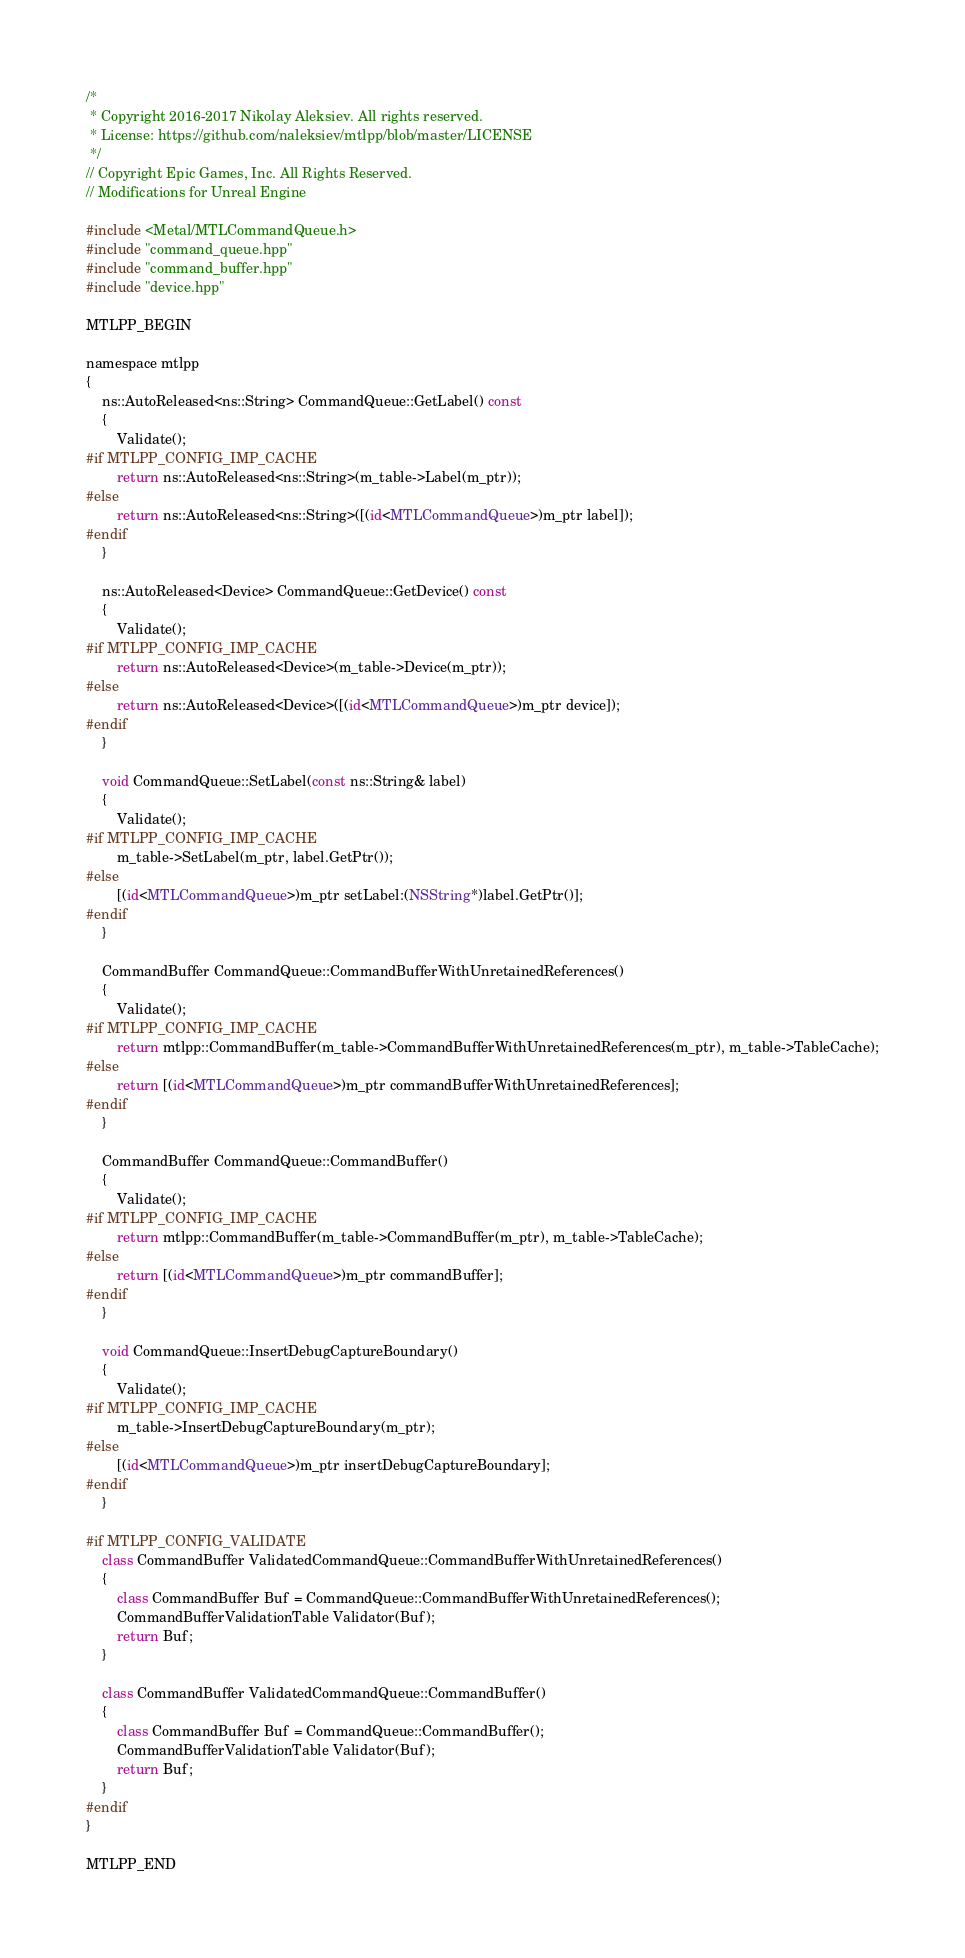Convert code to text. <code><loc_0><loc_0><loc_500><loc_500><_ObjectiveC_>/*
 * Copyright 2016-2017 Nikolay Aleksiev. All rights reserved.
 * License: https://github.com/naleksiev/mtlpp/blob/master/LICENSE
 */
// Copyright Epic Games, Inc. All Rights Reserved.
// Modifications for Unreal Engine

#include <Metal/MTLCommandQueue.h>
#include "command_queue.hpp"
#include "command_buffer.hpp"
#include "device.hpp"

MTLPP_BEGIN

namespace mtlpp
{
    ns::AutoReleased<ns::String> CommandQueue::GetLabel() const
    {
        Validate();
#if MTLPP_CONFIG_IMP_CACHE
		return ns::AutoReleased<ns::String>(m_table->Label(m_ptr));
#else
        return ns::AutoReleased<ns::String>([(id<MTLCommandQueue>)m_ptr label]);
#endif
    }

    ns::AutoReleased<Device> CommandQueue::GetDevice() const
    {
        Validate();
#if MTLPP_CONFIG_IMP_CACHE
		return ns::AutoReleased<Device>(m_table->Device(m_ptr));
#else
        return ns::AutoReleased<Device>([(id<MTLCommandQueue>)m_ptr device]);
#endif
    }

    void CommandQueue::SetLabel(const ns::String& label)
    {
        Validate();
#if MTLPP_CONFIG_IMP_CACHE
		m_table->SetLabel(m_ptr, label.GetPtr());
#else
        [(id<MTLCommandQueue>)m_ptr setLabel:(NSString*)label.GetPtr()];
#endif
    }

    CommandBuffer CommandQueue::CommandBufferWithUnretainedReferences()
    {
        Validate();
#if MTLPP_CONFIG_IMP_CACHE
		return mtlpp::CommandBuffer(m_table->CommandBufferWithUnretainedReferences(m_ptr), m_table->TableCache);
#else
        return [(id<MTLCommandQueue>)m_ptr commandBufferWithUnretainedReferences];
#endif
    }

    CommandBuffer CommandQueue::CommandBuffer()
    {
        Validate();
#if MTLPP_CONFIG_IMP_CACHE
		return mtlpp::CommandBuffer(m_table->CommandBuffer(m_ptr), m_table->TableCache);
#else
        return [(id<MTLCommandQueue>)m_ptr commandBuffer];
#endif
    }

    void CommandQueue::InsertDebugCaptureBoundary()
    {
        Validate();
#if MTLPP_CONFIG_IMP_CACHE
		m_table->InsertDebugCaptureBoundary(m_ptr);
#else
        [(id<MTLCommandQueue>)m_ptr insertDebugCaptureBoundary];
#endif
    }
	
#if MTLPP_CONFIG_VALIDATE
	class CommandBuffer ValidatedCommandQueue::CommandBufferWithUnretainedReferences()
	{
		class CommandBuffer Buf = CommandQueue::CommandBufferWithUnretainedReferences();
		CommandBufferValidationTable Validator(Buf);
		return Buf;
	}
	
	class CommandBuffer ValidatedCommandQueue::CommandBuffer()
	{
		class CommandBuffer Buf = CommandQueue::CommandBuffer();
		CommandBufferValidationTable Validator(Buf);
		return Buf;
	}
#endif
}

MTLPP_END
</code> 